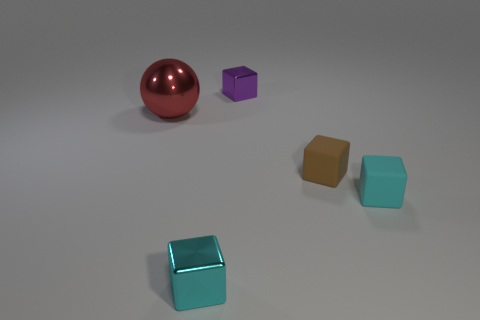What size is the cyan matte thing that is the same shape as the small brown object?
Make the answer very short. Small. The purple thing that is made of the same material as the large red object is what size?
Ensure brevity in your answer.  Small. How many matte things have the same color as the large ball?
Provide a short and direct response. 0. Is the number of tiny purple blocks left of the purple block less than the number of red metal objects that are to the right of the small cyan rubber cube?
Ensure brevity in your answer.  No. There is a shiny cube behind the large red ball; what is its size?
Offer a very short reply. Small. Are there any tiny cyan objects that have the same material as the tiny purple object?
Provide a succinct answer. Yes. Does the big thing have the same material as the tiny brown block?
Provide a succinct answer. No. There is another metallic block that is the same size as the cyan shiny block; what is its color?
Your answer should be very brief. Purple. How many other things are the same shape as the purple metallic object?
Your answer should be compact. 3. There is a red metal sphere; is its size the same as the cyan shiny block to the right of the ball?
Provide a short and direct response. No. 